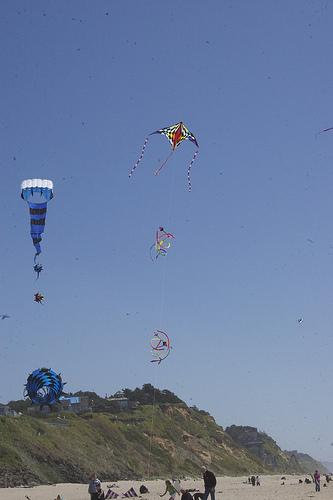Mention the key elements and activities visible in the image. Kites are flying, people walking and flying kites on a beach, a house on a hill, and a blue and white striped airplane in the sky. List the different objects and people visible in the image and their corresponding locations. Flying kites (sky), people on the beach (beach), house on the hill (hill), blue and white striped airplane (sky), giraffe (background), and man wearing a black shirt (beach). Highlight the main object in the image and its characteristics. The various kites flying in the sky are the main objects, showcasing a range of colors, patterns, and shapes, capturing the attention of viewers. Create a narrative description of the image. On a beautiful sunny day, vibrant kites dance in the sky, painting a picture of joy and freedom as people stroll and engage in activities on the beach, with a charming house overlooking the scene from a nearby hill. Discuss the overall ambiance and background of the image. The image portrays an idyllic and cheerful outdoor setting with a clear blue sky and inviting beach, where people engage in leisurely activities and kites fill the air. Summarize the scene in the image, including the activities taking place. Several kites are flying high in a beautiful sky as people on the beach take part in various activities and a house sits atop a grassy hill. Identify the main visual elements in the image and discuss them in a single sentence. Kites flying high in a serene, blue sky complement the cheerful energy of people along a sandy beach and the picturesque sight of a house atop a hill. Describe the color palette and theme of the image. The image is filled with bright, vivid colors and features kites, people enjoying coastal activities, and a picturesque hillside house, creating a joyful and lively atmosphere. Write a brief description of the image, focusing on the primary elements. Kites of various colors are soaring in a clear, blue sky, while people enjoy walking and flying kites on a sandy beach near a hill with a house on top. Provide an abstracted description of the scene in the image. A symphony of color and movement as kites soar high above an idyllic beach scene where people come together to enjoy nature's charms and a house nestles atop a hill. 